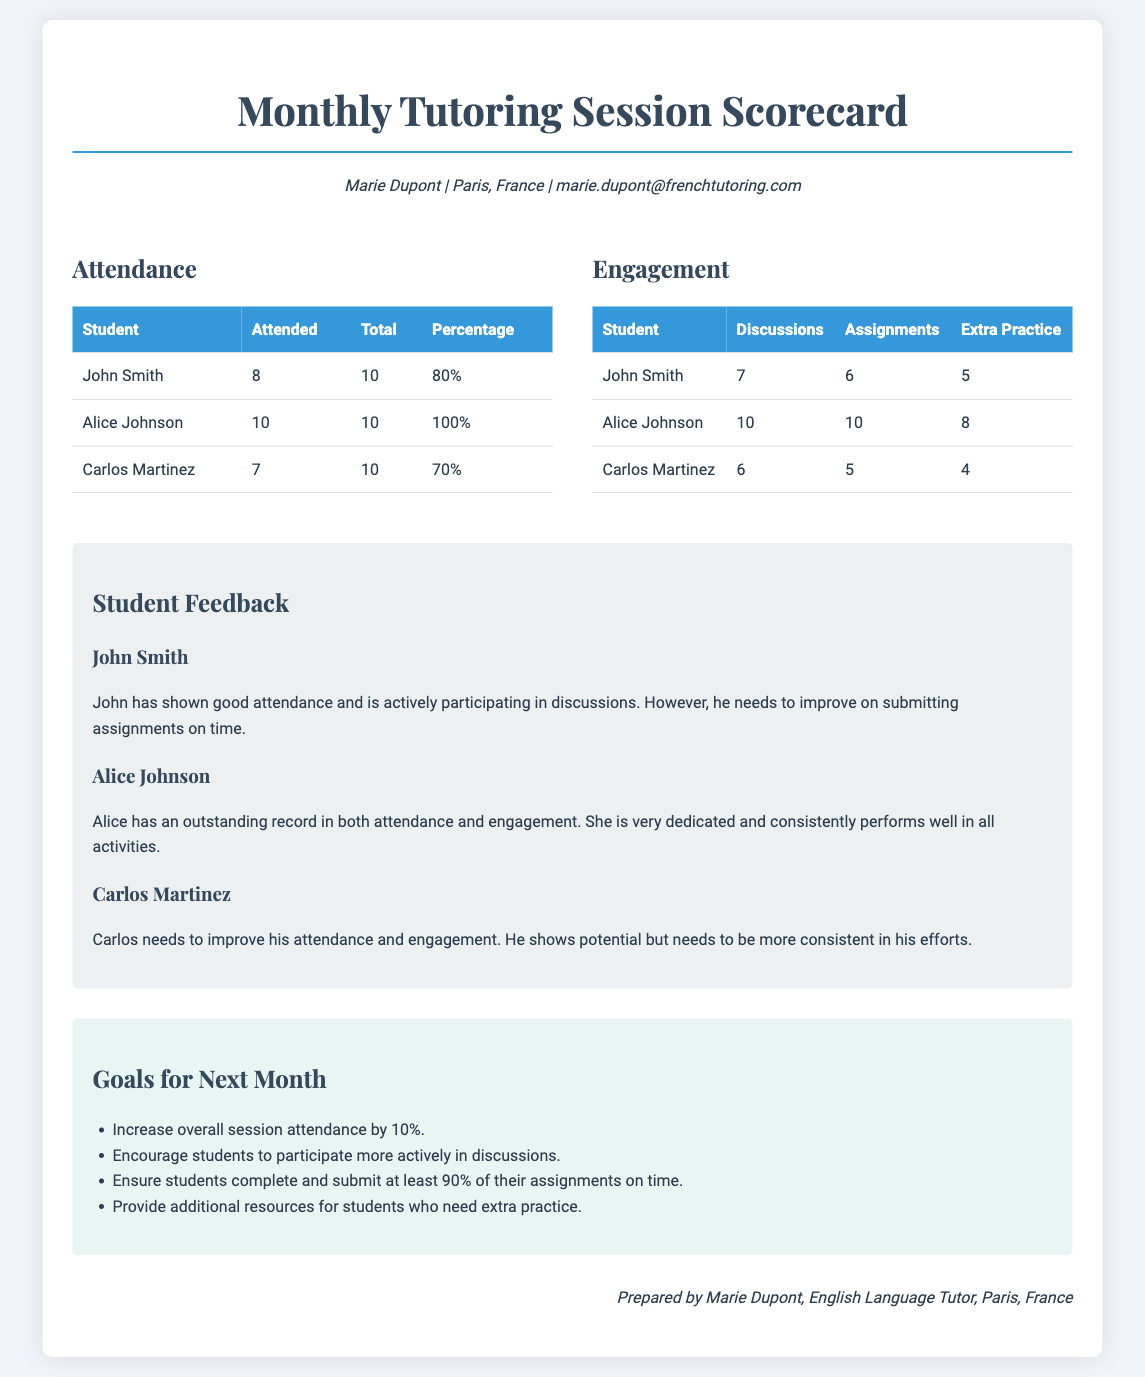What is the name of the tutor? The tutor's name is presented at the top of the document along with their contact information.
Answer: Marie Dupont How many sessions did Alice Johnson attend? The attendance table indicates the number of sessions attended for each student.
Answer: 10 What percentage of sessions did Carlos Martinez attend? The percentage of attendance is calculated in the attendance metrics section.
Answer: 70% How many discussions did John Smith participate in? The engagement table shows the number of discussions each student participated in.
Answer: 7 What is the goal related to assignments for next month? The goals section outlines specific targets for the upcoming month, particularly regarding assignment submissions.
Answer: Ensure students complete and submit at least 90% of their assignments on time Which student has the highest engagement metrics? By reviewing the engagement table, we can identify which student has the highest numbers across all categories.
Answer: Alice Johnson What feedback was given for Carlos Martinez? The feedback section provides specific comments regarding each student's performance and areas for improvement.
Answer: Carlos needs to improve his attendance and engagement What is the total number of discussions Alice Johnson participated in? The engagement metrics show the total discussions participated by each student.
Answer: 10 What improvement in attendance is targeted for next month? The goals section specifies the percentage increase aimed for student attendance in the upcoming month.
Answer: 10% 